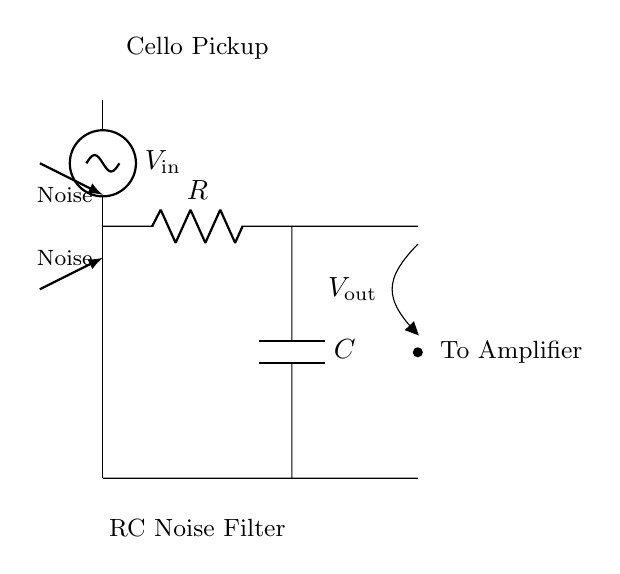What is the input voltage of the circuit? The input voltage is represented as V in the circuit, shown on the left side connected to the cello pickup.
Answer: V in What type of filter is represented in this circuit? This circuit is an RC noise filter, which is indicated by the presence of a resistor and capacitor connected in series to reduce noise signals.
Answer: RC noise filter What does the capacitor do in this circuit? The capacitor in this RC filter functions to block high-frequency noise while allowing low-frequency signals to pass, smoothing the output voltage.
Answer: Blocks high-frequency noise How is the output voltage labeled in the diagram? The output voltage is labeled as V out, which is located at the junction after the capacitor towards the amplifier.
Answer: V out What components are used in this filter circuit? The filter circuit comprises a resistor and a capacitor, which are essential for the RC filtering process.
Answer: Resistor and capacitor What is the primary purpose of this RC filter in the context of a cello's pickup system? The primary purpose of the RC filter in the cello's pickup system is to reduce noise, improving the quality of the sound signal being sent to the amplifier.
Answer: Reduce noise 